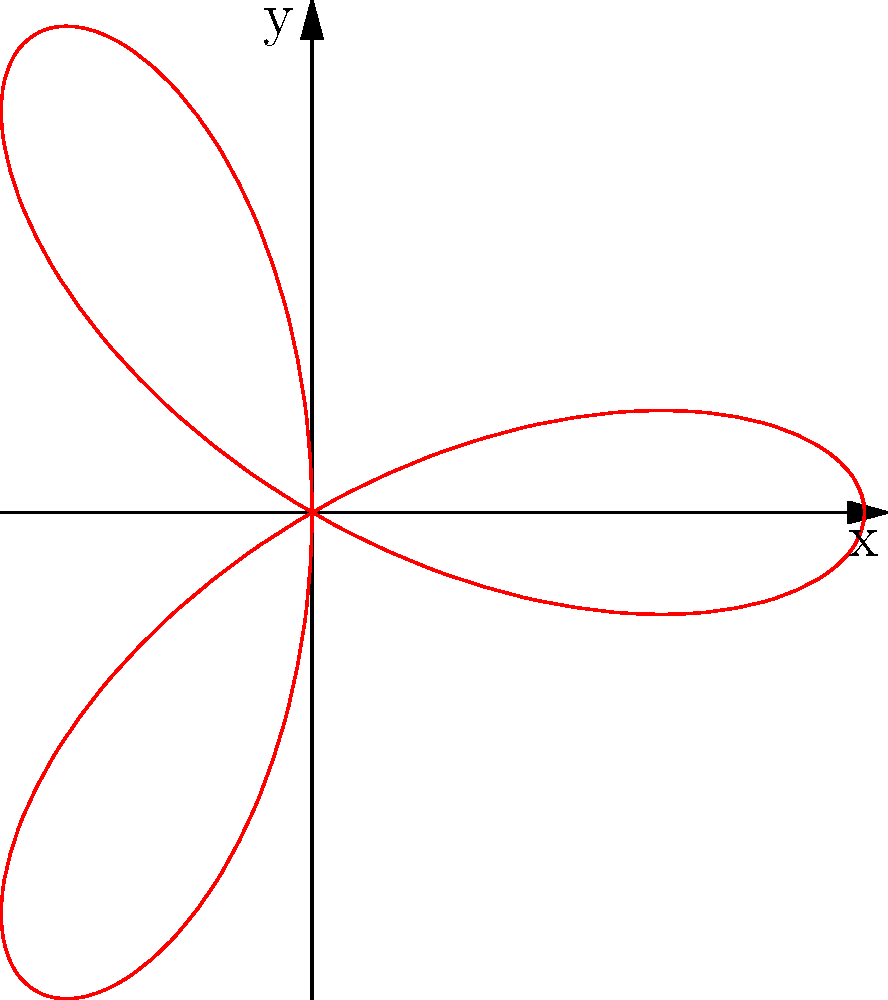As a junior engineer inspired by Craig Paylor's attention to detail, you're tasked with calculating the area enclosed by a polar rose curve given by the equation $r = 2\cos(3\theta)$. What is the total area enclosed by this curve? Let's approach this step-by-step:

1) The general formula for the area enclosed by a polar curve is:

   $$A = \frac{1}{2} \int_{0}^{2\pi} r^2(\theta) d\theta$$

2) In our case, $r = 2\cos(3\theta)$, so $r^2 = 4\cos^2(3\theta)$

3) Substituting this into our formula:

   $$A = \frac{1}{2} \int_{0}^{2\pi} 4\cos^2(3\theta) d\theta$$

4) We can simplify this using the identity $\cos^2(x) = \frac{1 + \cos(2x)}{2}$:

   $$A = 2 \int_{0}^{2\pi} \frac{1 + \cos(6\theta)}{2} d\theta$$

5) Simplifying:

   $$A = \int_{0}^{2\pi} (1 + \cos(6\theta)) d\theta$$

6) Integrating:

   $$A = [\theta + \frac{1}{6}\sin(6\theta)]_{0}^{2\pi}$$

7) Evaluating the bounds:

   $$A = (2\pi + 0) - (0 + 0) = 2\pi$$

Therefore, the total area enclosed by the curve is $2\pi$ square units.
Answer: $2\pi$ square units 